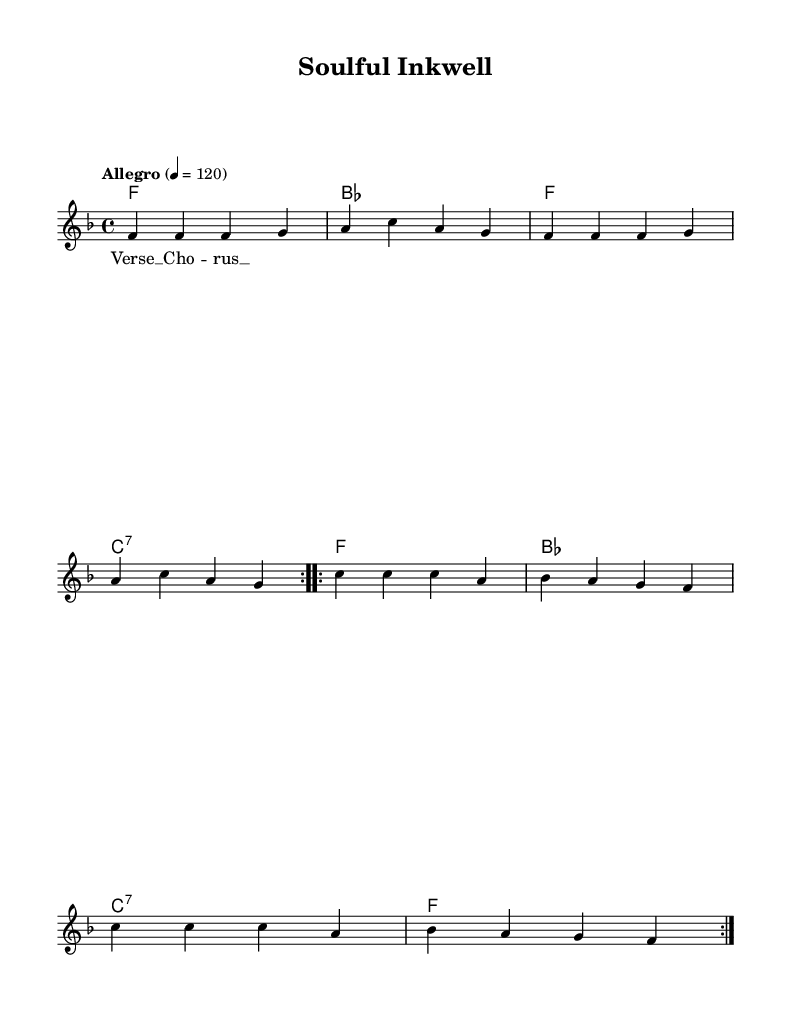What is the key signature of this music? The key signature is F major, which has one flat (B flat). You can identify this from the key signature marking at the beginning of the staff.
Answer: F major What is the time signature of the piece? The time signature is 4/4, indicated at the beginning of the score right after the key signature. This means there are four beats in each measure.
Answer: 4/4 What is the tempo marking for this music? The tempo marking is "Allegro" with a metronome marking of 120 beats per minute, specified at the beginning of the score. This indicates a fast pace.
Answer: Allegro, 120 How many measures are in the melody section? The melody section contains a total of eight measures, as indicated by the grouping of notes and the formatting in the score.
Answer: Eight What is the chord that corresponds to the first measure? The chord in the first measure is F major, noted in the chord symbols above the melody staff. You can see it clearly placed at the start of the first measure.
Answer: F What is the total number of volta sections in the music? There are two volta sections indicated in the score, shown by the repeated measures and the "volta" markings above the respective sections of music.
Answer: Two What type of song structure can be inferred from this sheet music? The song structure reflects a typical verse-chorus format, as suggested by the labeling of sections and the repetition of musical phrases.
Answer: Verse-Chorus 